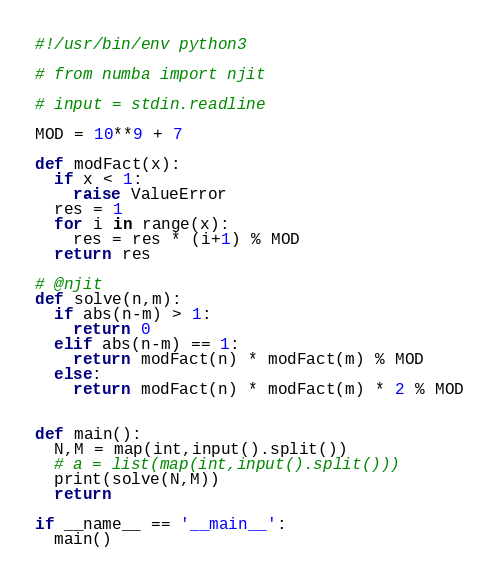<code> <loc_0><loc_0><loc_500><loc_500><_Python_>#!/usr/bin/env python3

# from numba import njit

# input = stdin.readline

MOD = 10**9 + 7

def modFact(x):
  if x < 1:
    raise ValueError
  res = 1
  for i in range(x):
    res = res * (i+1) % MOD
  return res

# @njit
def solve(n,m):
  if abs(n-m) > 1:
    return 0
  elif abs(n-m) == 1:
    return modFact(n) * modFact(m) % MOD
  else:
    return modFact(n) * modFact(m) * 2 % MOD


def main():
  N,M = map(int,input().split())
  # a = list(map(int,input().split()))
  print(solve(N,M))
  return

if __name__ == '__main__':
  main()
</code> 